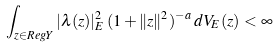<formula> <loc_0><loc_0><loc_500><loc_500>\int _ { z \in R e g Y } | \lambda ( z ) | ^ { 2 } _ { E } \, ( 1 + \| z \| ^ { 2 } ) ^ { - a } \, d V _ { E } ( z ) < \infty</formula> 